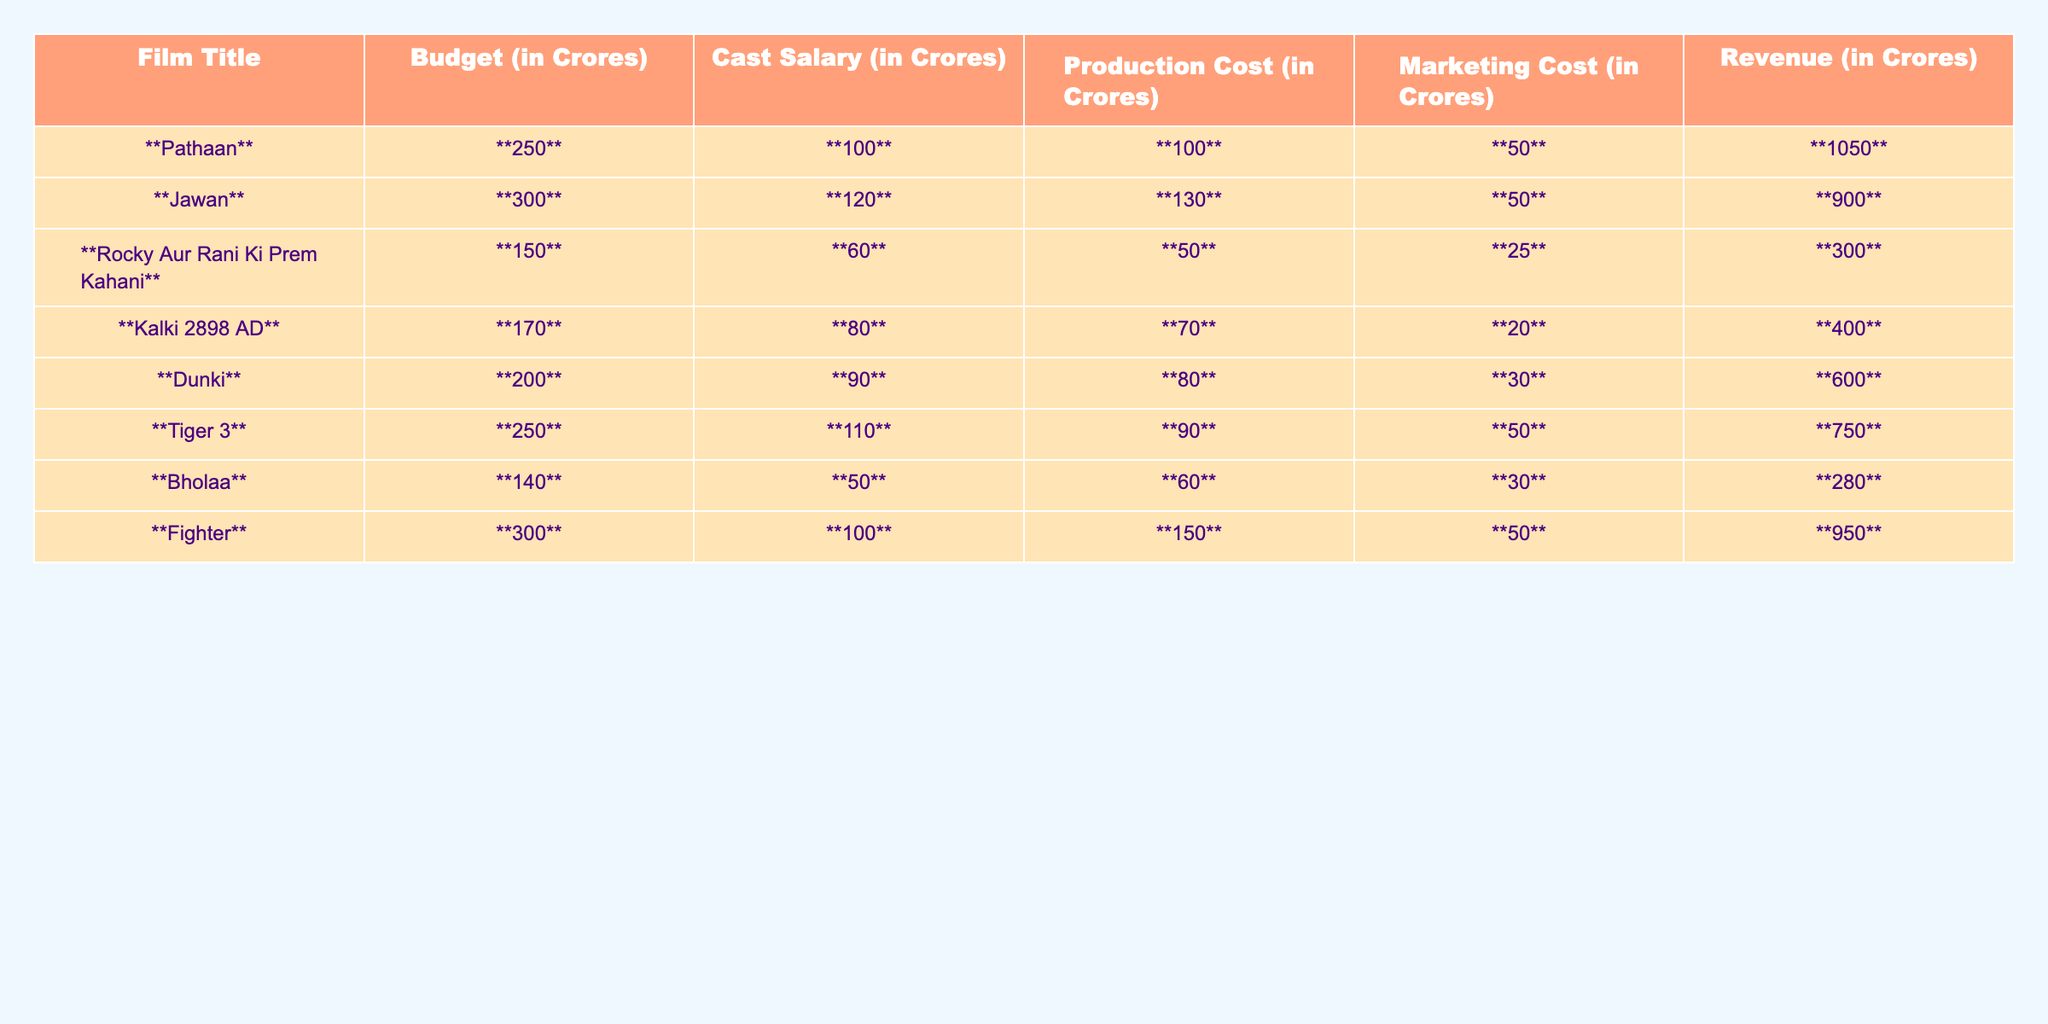What is the budget of the film "Pathaan"? The table shows that the budget for "Pathaan" is **250 Crores**.
Answer: 250 Crores Which film had the highest revenue in this list? By examining the revenue column, "Pathaan" has the highest revenue of **1050 Crores**.
Answer: Pathaan What is the total budget of all the films listed? The total budget can be calculated by adding the budgets: (250 + 300 + 150 + 170 + 200 + 250 + 140 + 300) = 1760 Crores.
Answer: 1760 Crores What percentage of the budget was spent on marketing for "Dunki"? The budget for "Dunki" is **200 Crores**, and the marketing cost is **30 Crores**. To find the percentage, divide 30 by 200 and multiply by 100: (30/200)*100 = 15%.
Answer: 15% Which film has the highest production cost, and what is that cost? Looking at the production cost column, "Fighter" has the highest production cost at **150 Crores**.
Answer: Fighter, 150 Crores Did "Bholaa" generate more revenue than its total budget? The budget for "Bholaa" is **140 Crores**, and its revenue is **280 Crores**. Since 280 is greater than 140, yes, it generated more revenue than its budget.
Answer: Yes What is the average cast salary of the films listed? To calculate the average cast salary, first, add all cast salaries: (100 + 120 + 60 + 80 + 90 + 110 + 50 + 100) = 710 Crores. Then divide by the number of films (8): 710/8 = 88.75 Crores.
Answer: 88.75 Crores How much more did "Jawan" spend on cast salary compared to "Rocky Aur Rani Ki Prem Kahani"? "Jawan" spent **120 Crores** on cast salary, while "Rocky Aur Rani Ki Prem Kahani" spent **60 Crores**. The difference is 120 - 60 = 60 Crores.
Answer: 60 Crores What is the total marketing cost for all films combined? The total marketing cost can be calculated by adding the marketing costs: (50 + 50 + 25 + 20 + 30 + 50 + 30 + 50) = 305 Crores.
Answer: 305 Crores If the total revenue of all films is considered, what is the profit for each film? The profit for each film can be calculated by subtracting the total budget from the revenue. For example, "Pathaan" has revenue of **1050 Crores** and a budget of **250 Crores**, so profit = 1050 - 250 = 800 Crores. This should be done for each film to find their individual profits.
Answer: Varies per film 